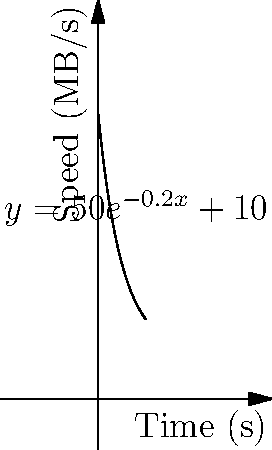A new data transfer protocol claims to achieve speeds represented by the function $f(x) = 50e^{-0.2x} + 10$, where $f(x)$ is the transfer speed in MB/s and $x$ is the time in seconds. Calculate the total amount of data transferred over the first 10 seconds. How does this compare to the theoretical maximum of a constant 60 MB/s transfer rate? 1) To find the total data transferred, we need to calculate the area under the curve from 0 to 10 seconds.

2) The integral to solve is:
   $$\int_0^{10} (50e^{-0.2x} + 10) dx$$

3) Split the integral:
   $$\int_0^{10} 50e^{-0.2x} dx + \int_0^{10} 10 dx$$

4) Solve the first part:
   $$[-250e^{-0.2x}]_0^{10} = -250e^{-2} + 250 = 250(1 - e^{-2})$$

5) Solve the second part:
   $$[10x]_0^{10} = 100$$

6) Sum the results:
   $$250(1 - e^{-2}) + 100 \approx 434.47 \text{ MB}$$

7) Compare to constant 60 MB/s:
   $$60 \text{ MB/s} \times 10 \text{ s} = 600 \text{ MB}$$

8) The new protocol transfers approximately 72.41% of the theoretical maximum.

This demonstrates that while traditional methods might claim a constant high speed, real-world protocols often have varying speeds that can be more accurately modeled and analyzed using calculus.
Answer: 434.47 MB, 72.41% of theoretical maximum 